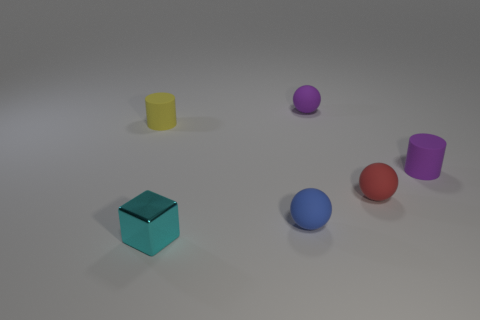Add 1 big gray spheres. How many objects exist? 7 Subtract all blue balls. How many balls are left? 2 Subtract all purple balls. How many balls are left? 2 Add 5 metal things. How many metal things exist? 6 Subtract 0 brown spheres. How many objects are left? 6 Subtract all blocks. How many objects are left? 5 Subtract 1 spheres. How many spheres are left? 2 Subtract all red cylinders. Subtract all yellow blocks. How many cylinders are left? 2 Subtract all blue things. Subtract all small balls. How many objects are left? 2 Add 3 cyan metal things. How many cyan metal things are left? 4 